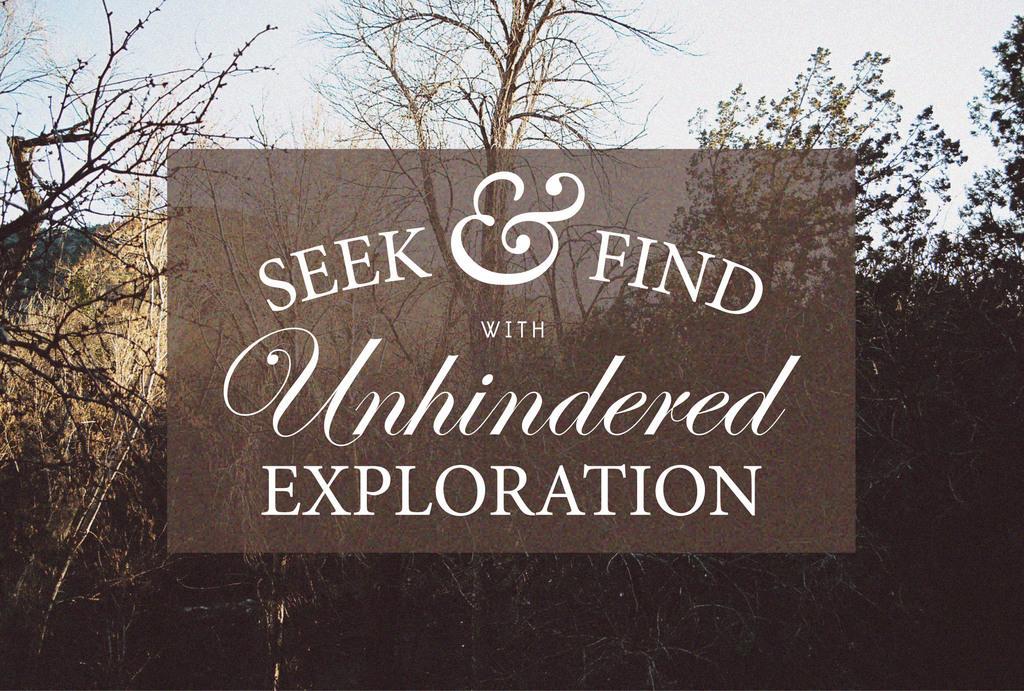Describe this image in one or two sentences. In this picture I can observe some text on the brown color background. In the background I can observe some trees and sky. 